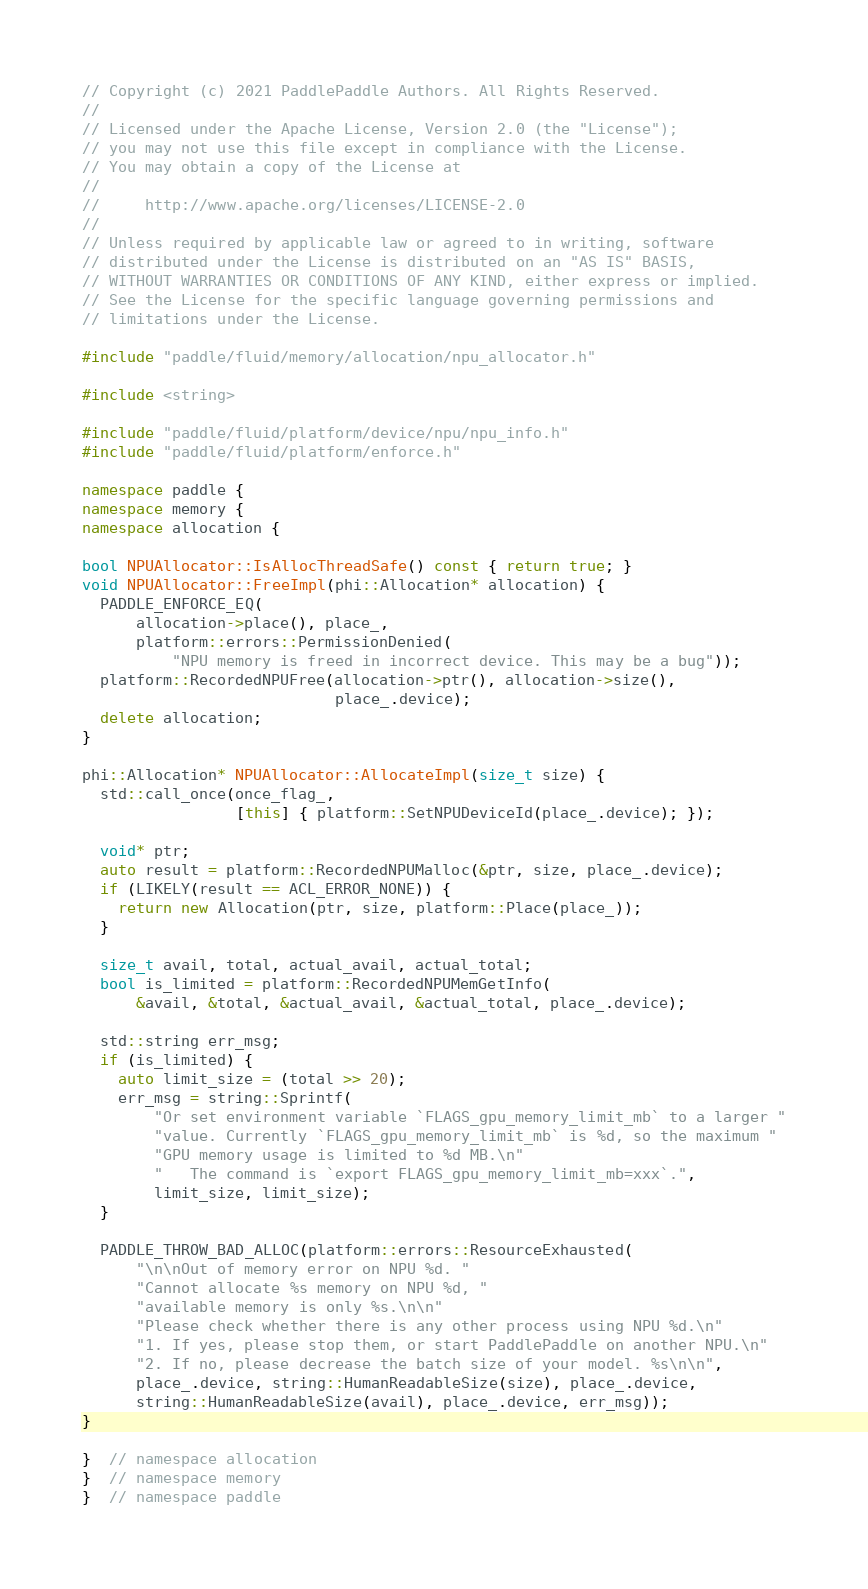Convert code to text. <code><loc_0><loc_0><loc_500><loc_500><_C++_>// Copyright (c) 2021 PaddlePaddle Authors. All Rights Reserved.
//
// Licensed under the Apache License, Version 2.0 (the "License");
// you may not use this file except in compliance with the License.
// You may obtain a copy of the License at
//
//     http://www.apache.org/licenses/LICENSE-2.0
//
// Unless required by applicable law or agreed to in writing, software
// distributed under the License is distributed on an "AS IS" BASIS,
// WITHOUT WARRANTIES OR CONDITIONS OF ANY KIND, either express or implied.
// See the License for the specific language governing permissions and
// limitations under the License.

#include "paddle/fluid/memory/allocation/npu_allocator.h"

#include <string>

#include "paddle/fluid/platform/device/npu/npu_info.h"
#include "paddle/fluid/platform/enforce.h"

namespace paddle {
namespace memory {
namespace allocation {

bool NPUAllocator::IsAllocThreadSafe() const { return true; }
void NPUAllocator::FreeImpl(phi::Allocation* allocation) {
  PADDLE_ENFORCE_EQ(
      allocation->place(), place_,
      platform::errors::PermissionDenied(
          "NPU memory is freed in incorrect device. This may be a bug"));
  platform::RecordedNPUFree(allocation->ptr(), allocation->size(),
                            place_.device);
  delete allocation;
}

phi::Allocation* NPUAllocator::AllocateImpl(size_t size) {
  std::call_once(once_flag_,
                 [this] { platform::SetNPUDeviceId(place_.device); });

  void* ptr;
  auto result = platform::RecordedNPUMalloc(&ptr, size, place_.device);
  if (LIKELY(result == ACL_ERROR_NONE)) {
    return new Allocation(ptr, size, platform::Place(place_));
  }

  size_t avail, total, actual_avail, actual_total;
  bool is_limited = platform::RecordedNPUMemGetInfo(
      &avail, &total, &actual_avail, &actual_total, place_.device);

  std::string err_msg;
  if (is_limited) {
    auto limit_size = (total >> 20);
    err_msg = string::Sprintf(
        "Or set environment variable `FLAGS_gpu_memory_limit_mb` to a larger "
        "value. Currently `FLAGS_gpu_memory_limit_mb` is %d, so the maximum "
        "GPU memory usage is limited to %d MB.\n"
        "   The command is `export FLAGS_gpu_memory_limit_mb=xxx`.",
        limit_size, limit_size);
  }

  PADDLE_THROW_BAD_ALLOC(platform::errors::ResourceExhausted(
      "\n\nOut of memory error on NPU %d. "
      "Cannot allocate %s memory on NPU %d, "
      "available memory is only %s.\n\n"
      "Please check whether there is any other process using NPU %d.\n"
      "1. If yes, please stop them, or start PaddlePaddle on another NPU.\n"
      "2. If no, please decrease the batch size of your model. %s\n\n",
      place_.device, string::HumanReadableSize(size), place_.device,
      string::HumanReadableSize(avail), place_.device, err_msg));
}

}  // namespace allocation
}  // namespace memory
}  // namespace paddle
</code> 